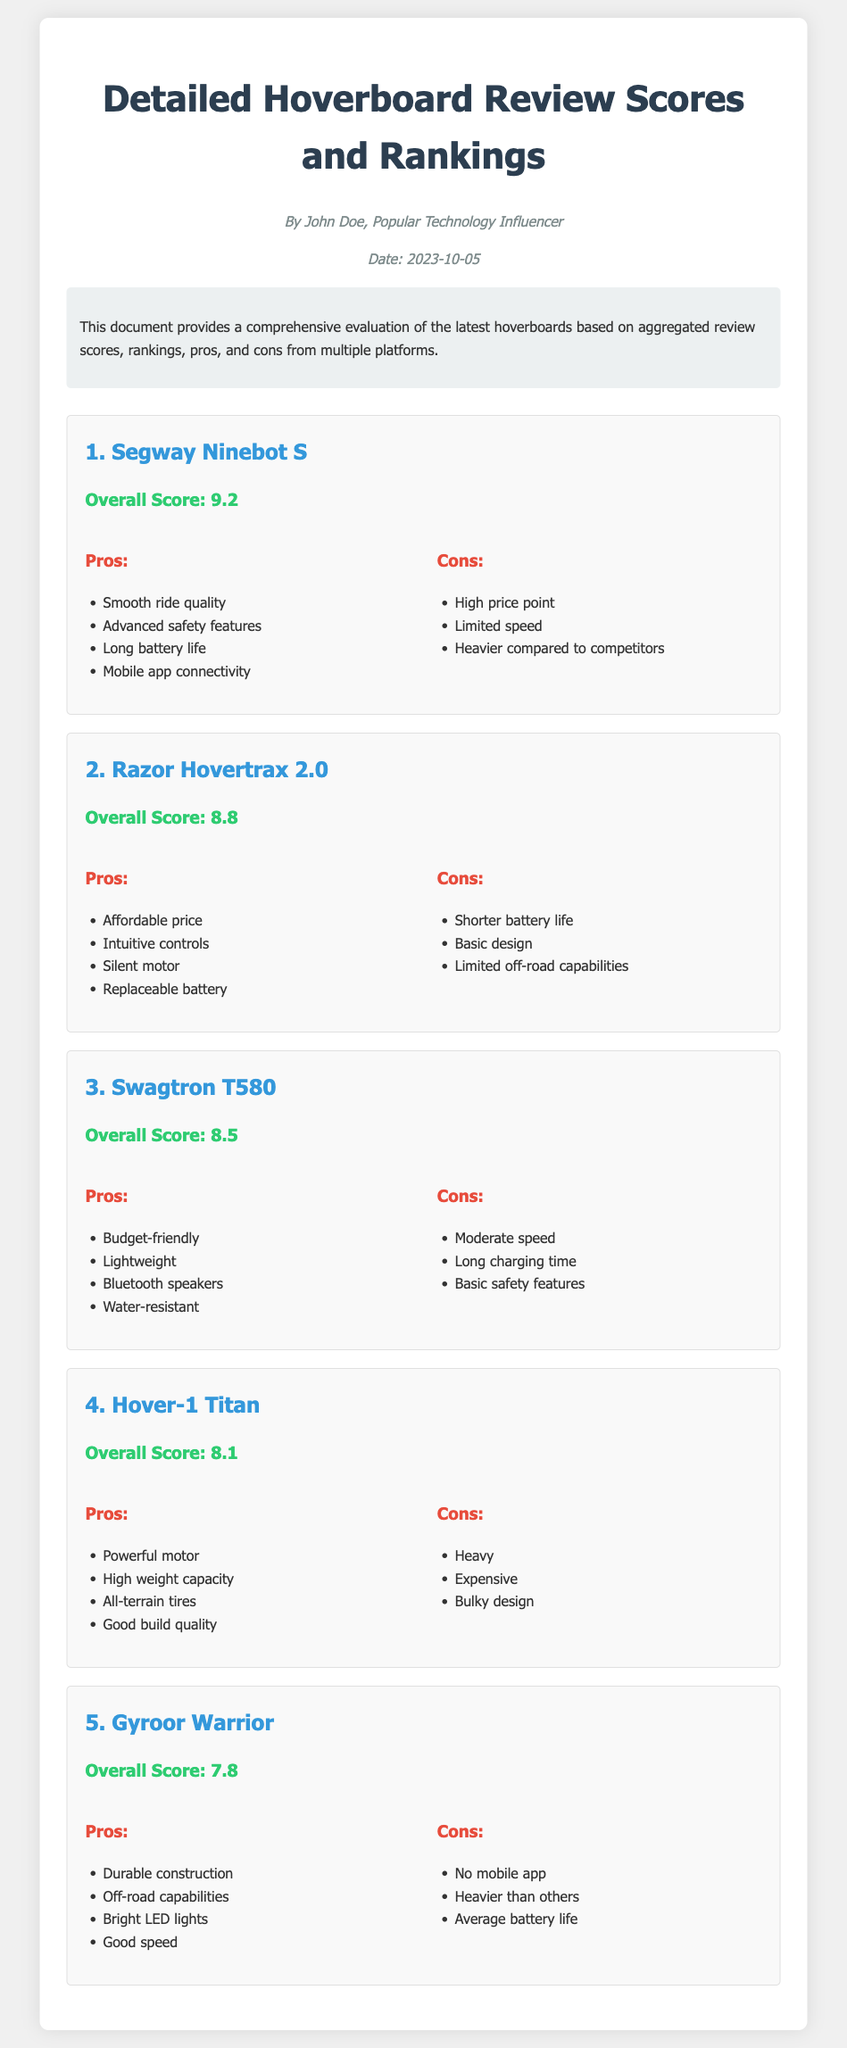What is the overall score of the Segway Ninebot S? The overall score for the Segway Ninebot S is specifically stated in the document as 9.2.
Answer: 9.2 Which hoverboard has the highest overall score? The document explicitly lists the Segway Ninebot S as having the highest overall score of 9.2.
Answer: Segway Ninebot S What are two pros of the Razor Hovertrax 2.0? The pros listed for the Razor Hovertrax 2.0 in the document include affordable price and intuitive controls.
Answer: Affordable price, Intuitive controls How many hoverboards are reviewed in the document? The document provides five hoverboards that are reviewed and ranked.
Answer: Five What is the main disadvantage of the Swagtron T580? Among listed cons in the document, the long charging time is highlighted as a key disadvantage of the Swagtron T580.
Answer: Long charging time Which hoverboard features Bluetooth speakers? The document specifies that the Swagtron T580 includes Bluetooth speakers listed in its pros section.
Answer: Swagtron T580 What is the publication date of the hoverboard review document? The document states that the review was published on October 5, 2023.
Answer: 2023-10-05 Which hoverboard is noted for off-road capabilities? The document indicates that the Gyroor Warrior is recognized for its off-road capabilities in the pros section.
Answer: Gyroor Warrior 